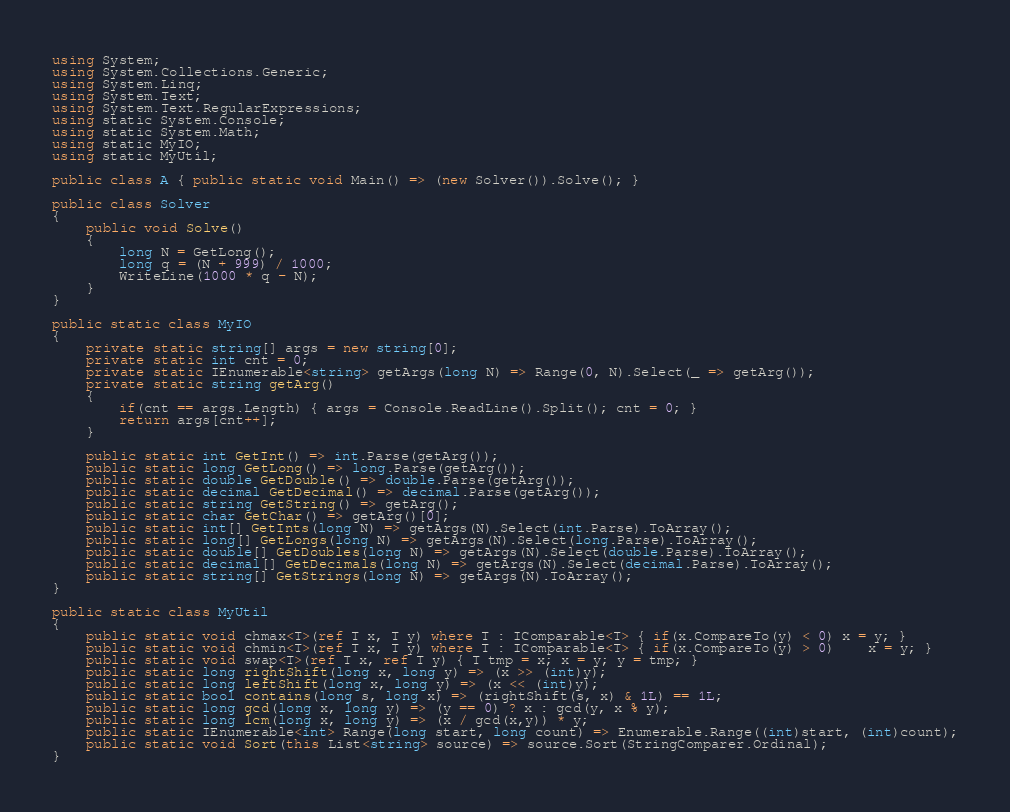<code> <loc_0><loc_0><loc_500><loc_500><_C#_>using System;
using System.Collections.Generic;
using System.Linq;
using System.Text;
using System.Text.RegularExpressions;
using static System.Console;
using static System.Math;
using static MyIO;
using static MyUtil;

public class A { public static void Main() => (new Solver()).Solve(); }

public class Solver
{
	public void Solve()
	{
		long N = GetLong();
		long q = (N + 999) / 1000;
		WriteLine(1000 * q - N);
	}
}

public static class MyIO
{
	private static string[] args = new string[0];
	private static int cnt = 0;
	private static IEnumerable<string> getArgs(long N) => Range(0, N).Select(_ => getArg());
	private static string getArg()
	{
		if(cnt == args.Length) { args = Console.ReadLine().Split(); cnt = 0; }
		return args[cnt++];
	}

	public static int GetInt() => int.Parse(getArg());
	public static long GetLong() => long.Parse(getArg());
	public static double GetDouble() => double.Parse(getArg());
	public static decimal GetDecimal() => decimal.Parse(getArg());
	public static string GetString() => getArg();
	public static char GetChar() => getArg()[0];
	public static int[] GetInts(long N) => getArgs(N).Select(int.Parse).ToArray();
	public static long[] GetLongs(long N) => getArgs(N).Select(long.Parse).ToArray();
	public static double[] GetDoubles(long N) => getArgs(N).Select(double.Parse).ToArray();
	public static decimal[] GetDecimals(long N) => getArgs(N).Select(decimal.Parse).ToArray();
	public static string[] GetStrings(long N) => getArgs(N).ToArray();
}

public static class MyUtil
{
	public static void chmax<T>(ref T x, T y) where T : IComparable<T> { if(x.CompareTo(y) < 0) x = y; }
	public static void chmin<T>(ref T x, T y) where T : IComparable<T> { if(x.CompareTo(y) > 0)	x = y; }
	public static void swap<T>(ref T x, ref T y) { T tmp = x; x = y; y = tmp; }
	public static long rightShift(long x, long y) => (x >> (int)y);
	public static long leftShift(long x, long y) => (x << (int)y);
	public static bool contains(long s, long x) => (rightShift(s, x) & 1L) == 1L;
	public static long gcd(long x, long y) => (y == 0) ? x : gcd(y, x % y);
	public static long lcm(long x, long y) => (x / gcd(x,y)) * y;	
	public static IEnumerable<int> Range(long start, long count) => Enumerable.Range((int)start, (int)count);
	public static void Sort(this List<string> source) => source.Sort(StringComparer.Ordinal);
}
</code> 